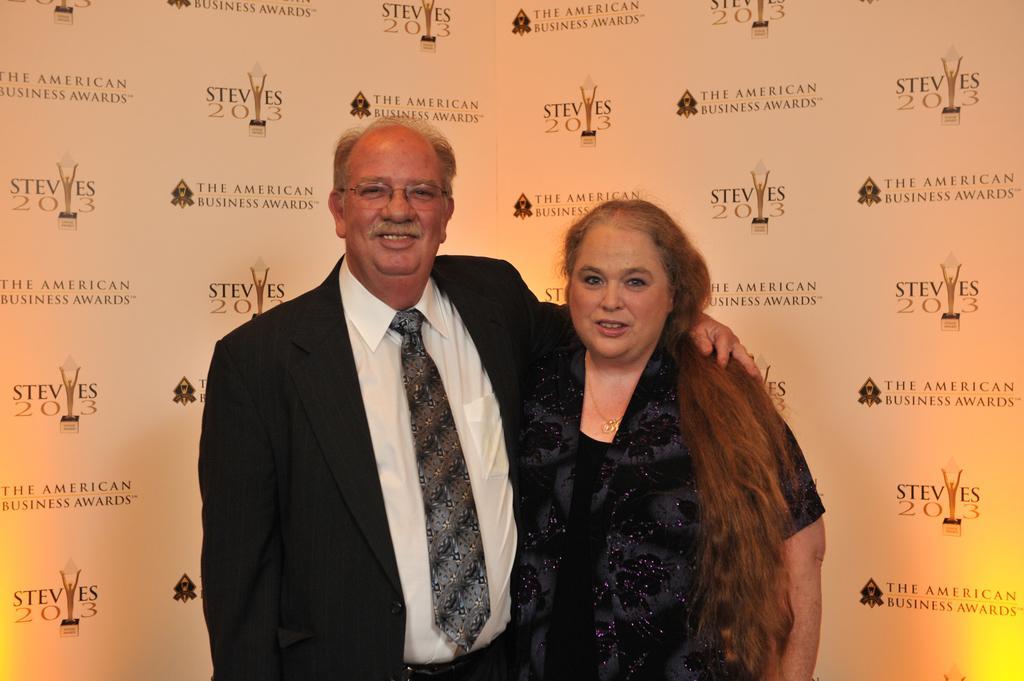How would you summarize this image in a sentence or two? In this picture we can see a man and a woman are standing and smiling, in the background there are some logos and text. 